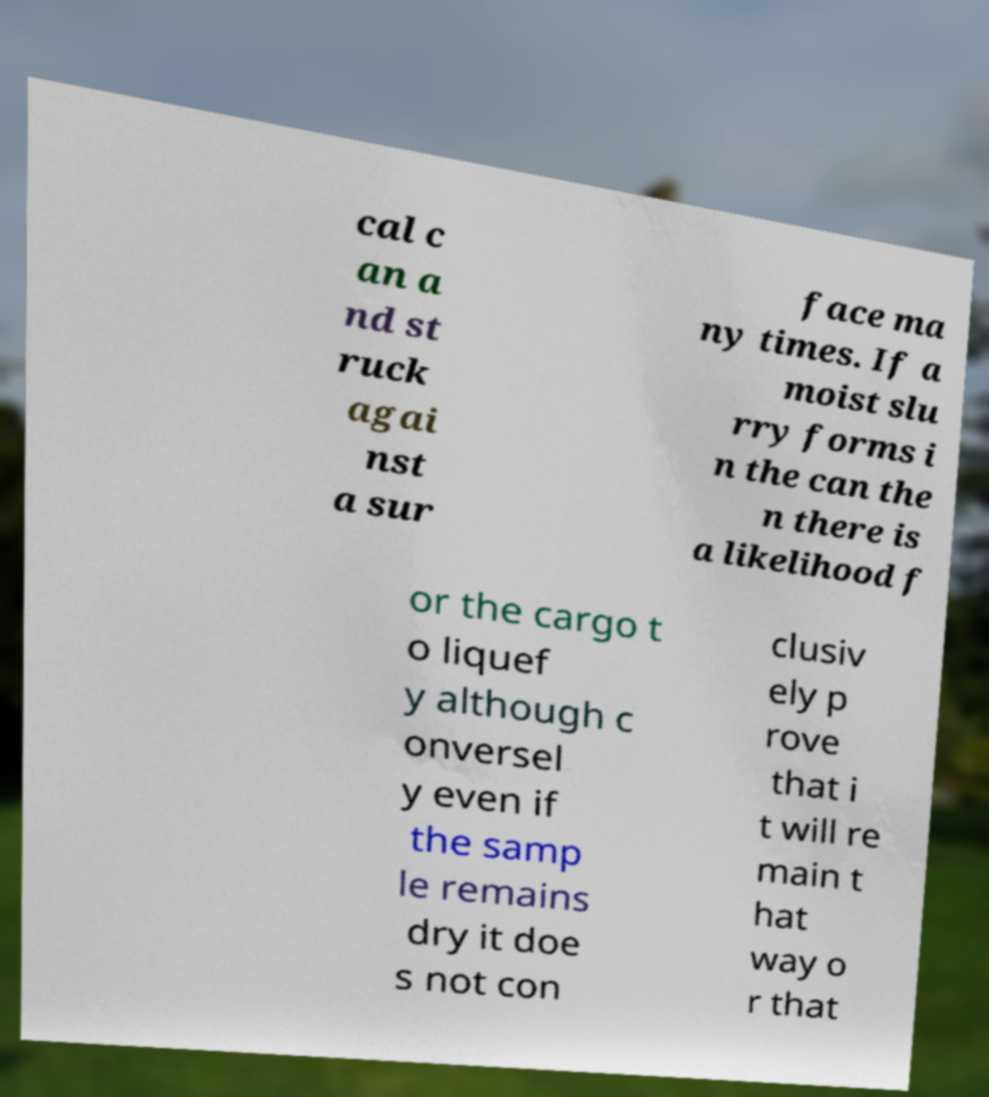Please identify and transcribe the text found in this image. cal c an a nd st ruck agai nst a sur face ma ny times. If a moist slu rry forms i n the can the n there is a likelihood f or the cargo t o liquef y although c onversel y even if the samp le remains dry it doe s not con clusiv ely p rove that i t will re main t hat way o r that 